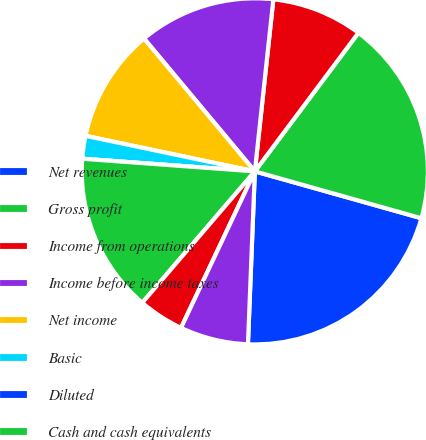Convert chart to OTSL. <chart><loc_0><loc_0><loc_500><loc_500><pie_chart><fcel>Net revenues<fcel>Gross profit<fcel>Income from operations<fcel>Income before income taxes<fcel>Net income<fcel>Basic<fcel>Diluted<fcel>Cash and cash equivalents<fcel>Short-term investments<fcel>Long-term investments<nl><fcel>21.27%<fcel>19.15%<fcel>8.51%<fcel>12.77%<fcel>10.64%<fcel>2.13%<fcel>0.0%<fcel>14.89%<fcel>4.26%<fcel>6.38%<nl></chart> 